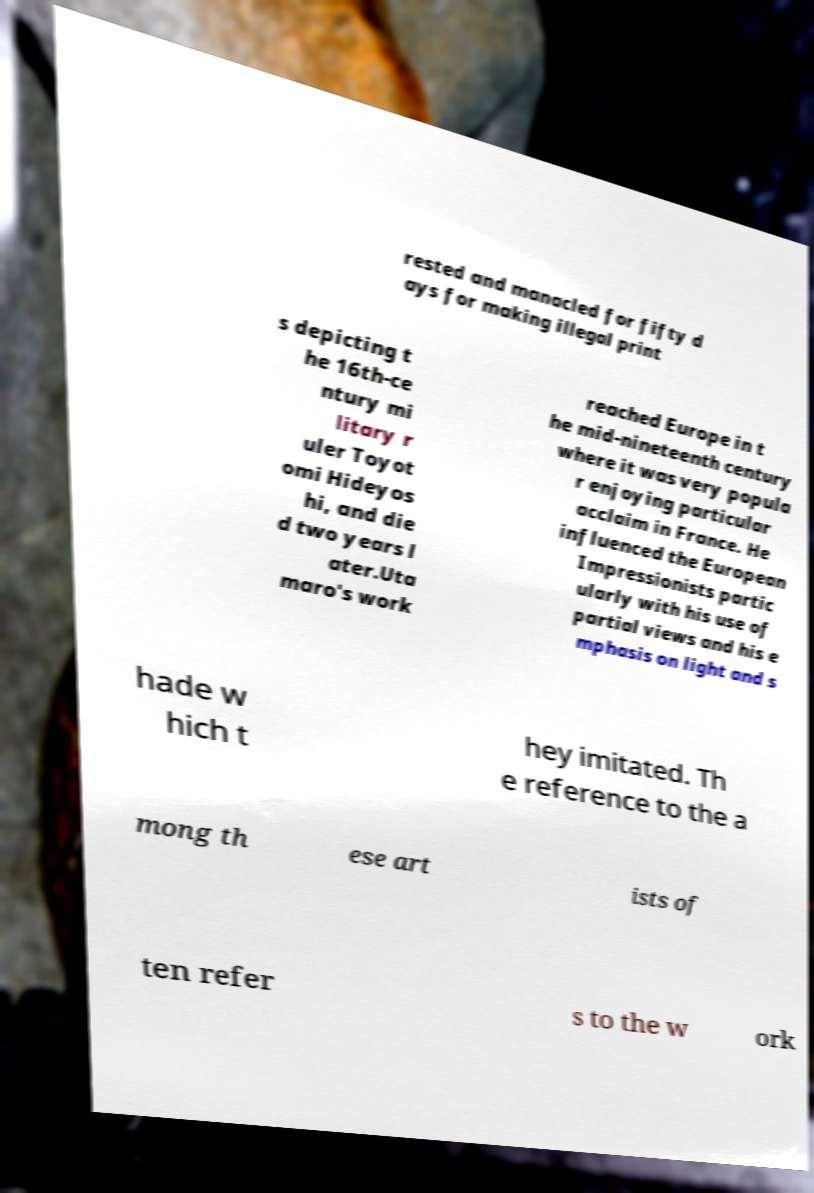Can you read and provide the text displayed in the image?This photo seems to have some interesting text. Can you extract and type it out for me? rested and manacled for fifty d ays for making illegal print s depicting t he 16th-ce ntury mi litary r uler Toyot omi Hideyos hi, and die d two years l ater.Uta maro's work reached Europe in t he mid-nineteenth century where it was very popula r enjoying particular acclaim in France. He influenced the European Impressionists partic ularly with his use of partial views and his e mphasis on light and s hade w hich t hey imitated. Th e reference to the a mong th ese art ists of ten refer s to the w ork 